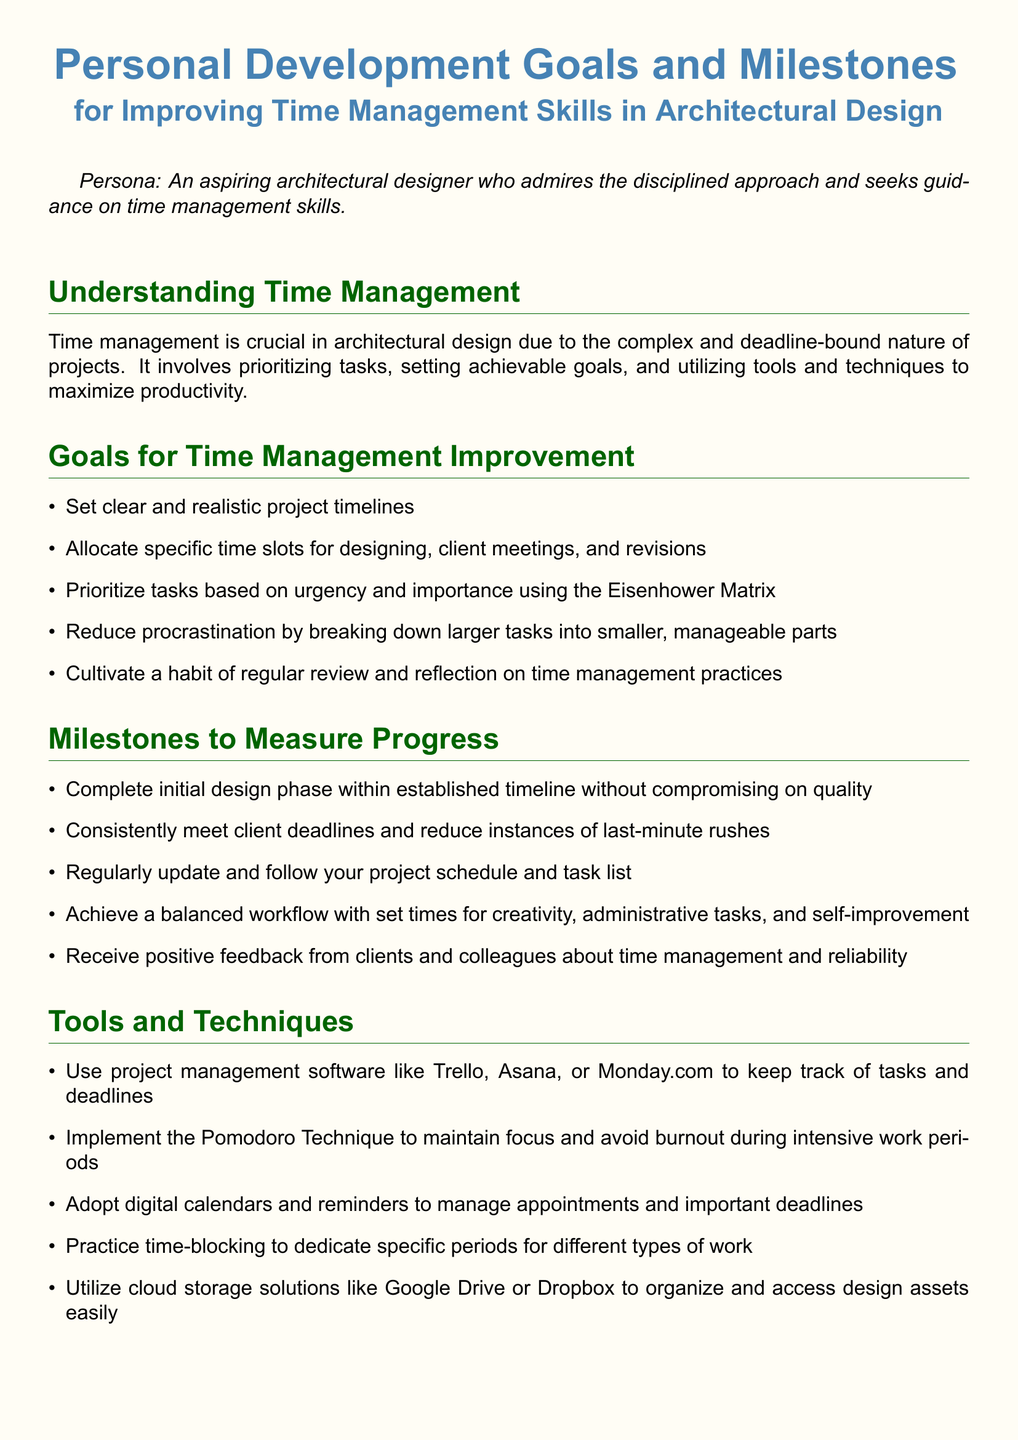What is the persona described in the document? The persona is an aspiring architectural designer who admires the disciplined approach and seeks guidance on time management skills.
Answer: An aspiring architectural designer What is one goal for time management improvement? The document lists multiple goals, and one of them involves setting clear and realistic project timelines.
Answer: Set clear and realistic project timelines Which technique is suggested to maintain focus? The document recommends using the Pomodoro Technique to maintain focus and avoid burnout during intensive work periods.
Answer: Pomodoro Technique How many self-assessment questions are included in the document? The document lists a total of five self-assessment questions.
Answer: Five What is a milestone to measure progress in time management? One of the milestones mentioned is consistently meeting client deadlines and reducing instances of last-minute rushes.
Answer: Consistently meet client deadlines What tool is suggested for project management? The document suggests using project management software like Trello.
Answer: Trello What habit should be cultivated according to the goals section? The document states that one should cultivate a habit of regular review and reflection on time management practices.
Answer: Regular review and reflection What type of approach does the persona admire? The persona admires a disciplined approach as stated in the document.
Answer: Disciplined approach Which storage solution is recommended for organizing design assets? The document suggests utilizing cloud storage solutions like Google Drive or Dropbox.
Answer: Google Drive or Dropbox 